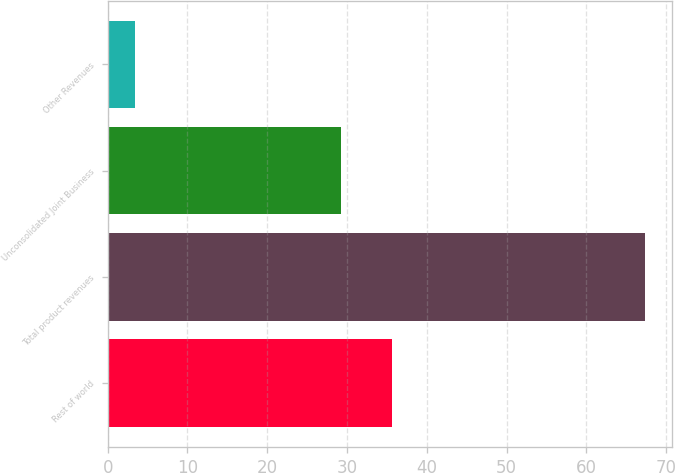Convert chart to OTSL. <chart><loc_0><loc_0><loc_500><loc_500><bar_chart><fcel>Rest of world<fcel>Total product revenues<fcel>Unconsolidated Joint Business<fcel>Other Revenues<nl><fcel>35.6<fcel>67.4<fcel>29.2<fcel>3.4<nl></chart> 